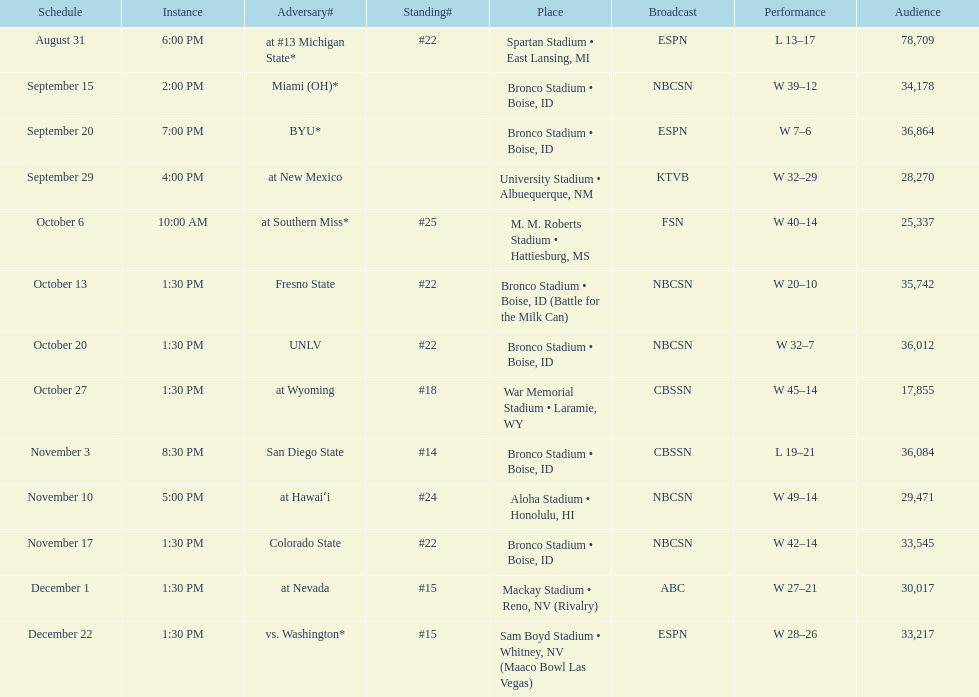Number of points scored by miami (oh) against the broncos. 12. 